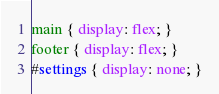Convert code to text. <code><loc_0><loc_0><loc_500><loc_500><_CSS_>main { display: flex; }
footer { display: flex; }
#settings { display: none; }</code> 